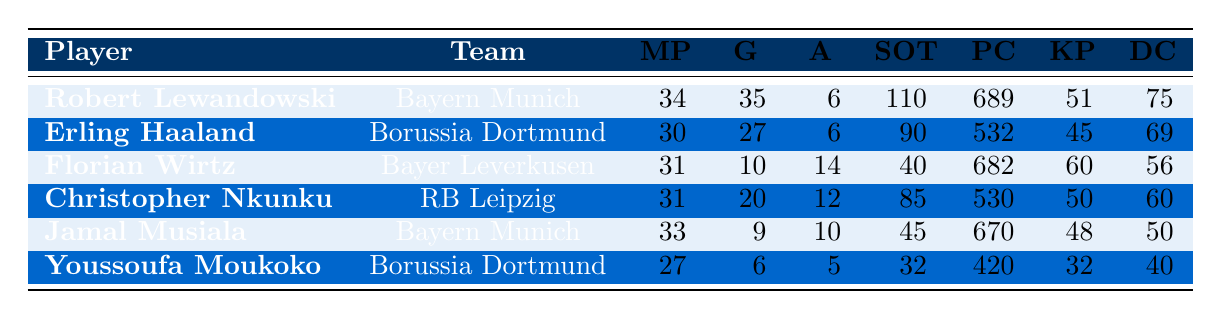What player scored the most goals? Robert Lewandowski scored the highest number of goals with a total of 35. He played 34 matches, and this information is directly evident in the table.
Answer: Robert Lewandowski How many assists did Florian Wirtz provide? According to the table, Florian Wirtz provided 14 assists in 31 matches. This value can be found in the corresponding row for Wirtz.
Answer: 14 What is the total number of goals scored by players from Bayern Munich? Bayern Munich players (Robert Lewandowski and Jamal Musiala) scored a total of (35 + 9) = 44 goals. This requires summing the goals from both players.
Answer: 44 Did Erling Haaland have more shots on target than Youssoufa Moukoko? Erling Haaland had 90 shots on target while Youssoufa Moukoko had 32. Since 90 is greater than 32, the statement is true.
Answer: Yes Which player completed the most passes? By looking at the table, Robert Lewandowski completed 689 passes, which is the highest among all players listed. This is directly identifiable from the table.
Answer: Robert Lewandowski What is the average number of goals scored by all players listed? The total number of goals scored is (35 + 27 + 10 + 20 + 9 + 6) = 107, and there are 6 players. To find the average, divide the total by the number of players: 107 / 6 ≈ 17.83.
Answer: 17.83 How many players scored fewer than 10 goals? From the table, both Jamal Musiala and Youssoufa Moukoko scored fewer than 10 goals, which gives a total of 2 players meeting this criterion.
Answer: 2 Was the total number of assists from all Windows players greater than 30? Combining the assists; Robert Lewandowski (6) + Erling Haaland (6) + Florian Wirtz (14) + Christopher Nkunku (12) + Jamal Musiala (10) + Youssoufa Moukoko (5) = 53. Since 53 is greater than 30, the answer is yes.
Answer: Yes 